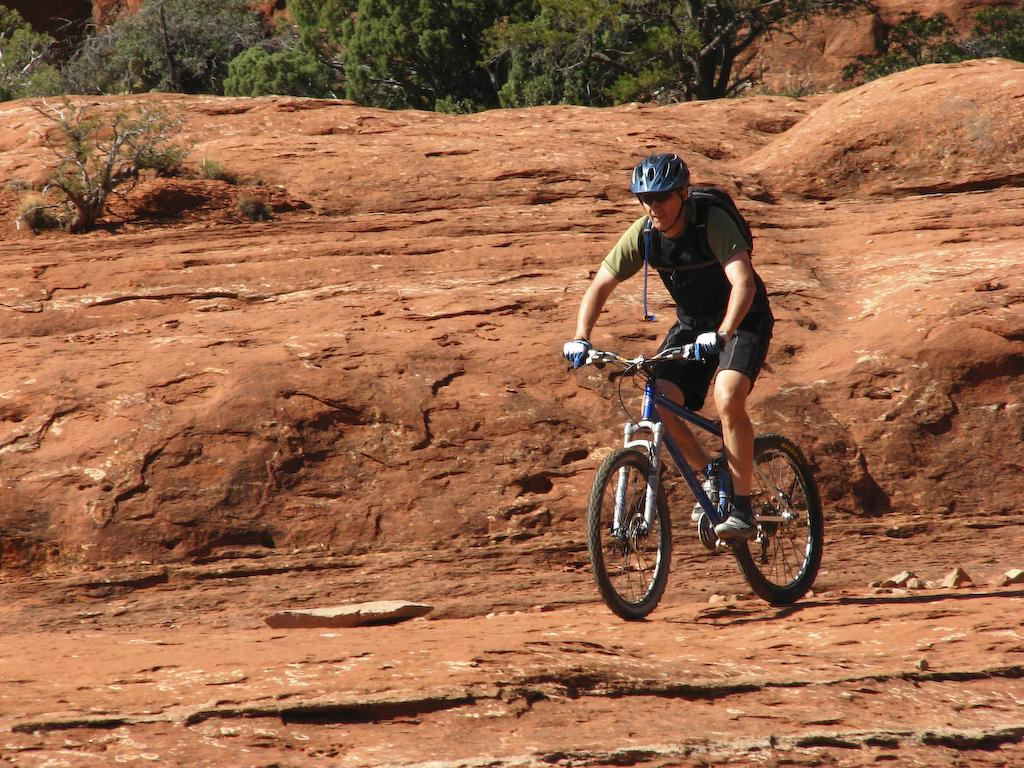What type of vegetation can be seen in the background of the image? There are trees in the background of the image. What other plant is visible in the image? There is a plant in the image. What is the man in the image wearing? The man is wearing goggles, a helmet, a backpack, and gloves. What activity is the man engaged in? The man is riding a bicycle. How many chairs are visible in the image? There are no chairs present in the image. What type of cactus can be seen in the image? There is no cactus present in the image. 